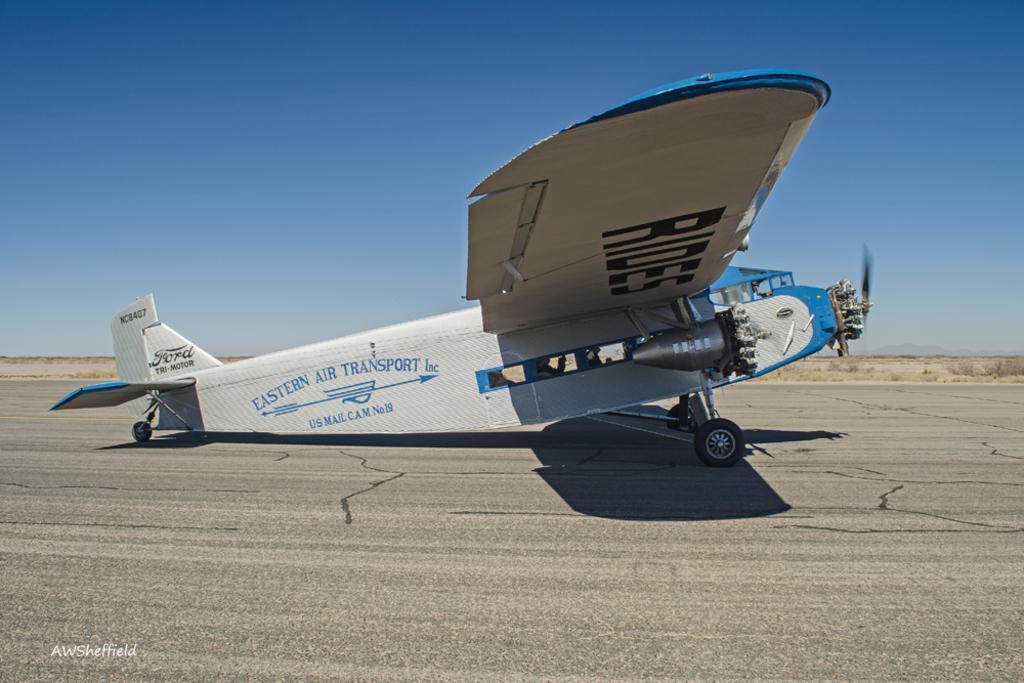Could you give a brief overview of what you see in this image? In this picture I can see an aircraft in the middle, there is a watermark in the bottom left hand side. At the top I can see the sky. 